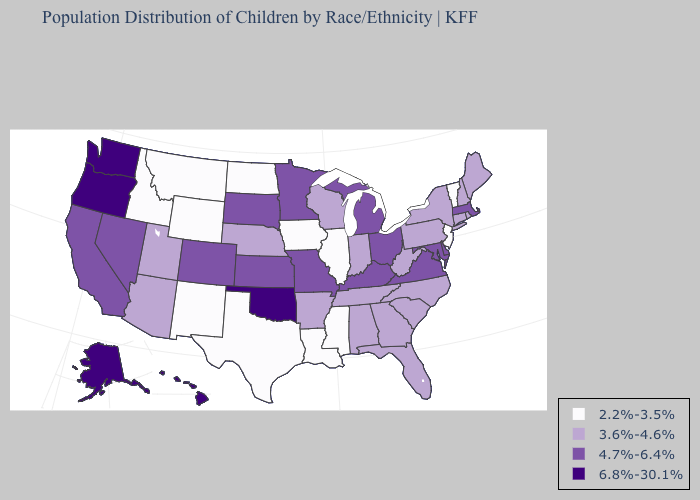Name the states that have a value in the range 3.6%-4.6%?
Short answer required. Alabama, Arizona, Arkansas, Connecticut, Florida, Georgia, Indiana, Maine, Nebraska, New Hampshire, New York, North Carolina, Pennsylvania, Rhode Island, South Carolina, Tennessee, Utah, West Virginia, Wisconsin. What is the highest value in the MidWest ?
Be succinct. 4.7%-6.4%. What is the value of Minnesota?
Keep it brief. 4.7%-6.4%. Name the states that have a value in the range 4.7%-6.4%?
Give a very brief answer. California, Colorado, Delaware, Kansas, Kentucky, Maryland, Massachusetts, Michigan, Minnesota, Missouri, Nevada, Ohio, South Dakota, Virginia. How many symbols are there in the legend?
Write a very short answer. 4. Name the states that have a value in the range 3.6%-4.6%?
Write a very short answer. Alabama, Arizona, Arkansas, Connecticut, Florida, Georgia, Indiana, Maine, Nebraska, New Hampshire, New York, North Carolina, Pennsylvania, Rhode Island, South Carolina, Tennessee, Utah, West Virginia, Wisconsin. Does Ohio have the lowest value in the MidWest?
Be succinct. No. What is the value of Alabama?
Be succinct. 3.6%-4.6%. What is the lowest value in the Northeast?
Concise answer only. 2.2%-3.5%. What is the lowest value in the USA?
Short answer required. 2.2%-3.5%. What is the value of Hawaii?
Quick response, please. 6.8%-30.1%. What is the highest value in states that border Iowa?
Keep it brief. 4.7%-6.4%. Does Maryland have the highest value in the USA?
Concise answer only. No. Does Alaska have the highest value in the USA?
Concise answer only. Yes. What is the lowest value in the South?
Answer briefly. 2.2%-3.5%. 